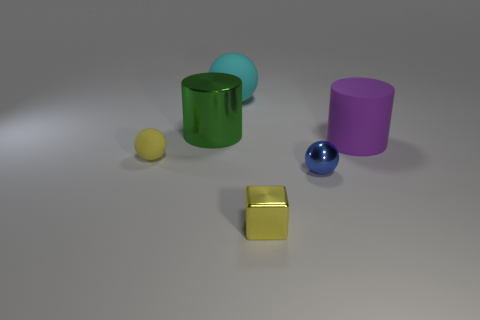Do the yellow shiny thing and the blue metal thing have the same size?
Give a very brief answer. Yes. Is there anything else that is the same color as the small matte object?
Keep it short and to the point. Yes. The tiny thing that is both behind the tiny block and right of the cyan matte ball has what shape?
Give a very brief answer. Sphere. How big is the rubber object that is behind the big purple cylinder?
Your answer should be very brief. Large. There is a small yellow thing that is on the left side of the metal thing that is behind the yellow sphere; what number of green shiny objects are behind it?
Provide a succinct answer. 1. Are there any large matte objects left of the blue metal ball?
Make the answer very short. Yes. What number of other objects are the same size as the cyan thing?
Offer a very short reply. 2. What is the ball that is behind the blue object and in front of the large matte cylinder made of?
Make the answer very short. Rubber. There is a large object that is in front of the green metallic cylinder; is its shape the same as the large object that is left of the big cyan object?
Give a very brief answer. Yes. There is a big object that is behind the big cylinder on the left side of the big cylinder that is on the right side of the large cyan object; what shape is it?
Your response must be concise. Sphere. 